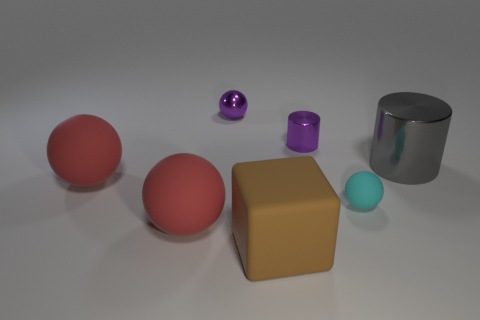Subtract all rubber balls. How many balls are left? 1 Subtract all gray balls. Subtract all yellow blocks. How many balls are left? 4 Add 3 purple cylinders. How many objects exist? 10 Subtract all spheres. How many objects are left? 3 Subtract 0 yellow spheres. How many objects are left? 7 Subtract all small red metallic cylinders. Subtract all tiny rubber balls. How many objects are left? 6 Add 6 big things. How many big things are left? 10 Add 5 big cyan matte things. How many big cyan matte things exist? 5 